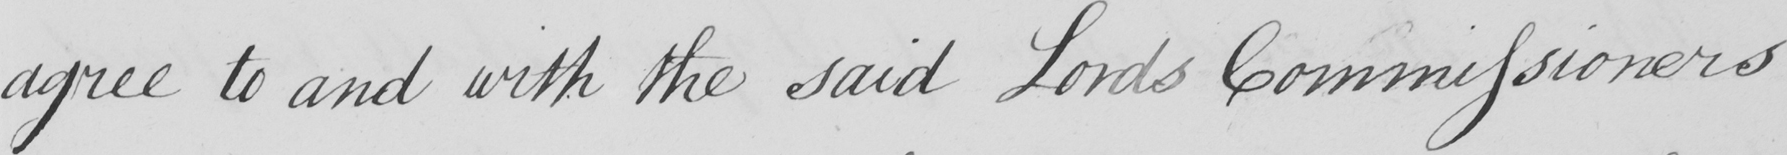Can you tell me what this handwritten text says? agree to and with the said Lords Commissioners 